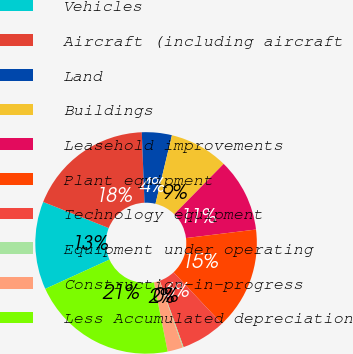<chart> <loc_0><loc_0><loc_500><loc_500><pie_chart><fcel>Vehicles<fcel>Aircraft (including aircraft<fcel>Land<fcel>Buildings<fcel>Leasehold improvements<fcel>Plant equipment<fcel>Technology equipment<fcel>Equipment under operating<fcel>Construction-in-progress<fcel>Less Accumulated depreciation<nl><fcel>12.84%<fcel>18.35%<fcel>4.37%<fcel>8.6%<fcel>10.72%<fcel>14.95%<fcel>6.48%<fcel>0.13%<fcel>2.25%<fcel>21.31%<nl></chart> 